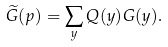Convert formula to latex. <formula><loc_0><loc_0><loc_500><loc_500>\widetilde { G } ( p ) = \sum _ { y } Q ( y ) G ( y ) .</formula> 